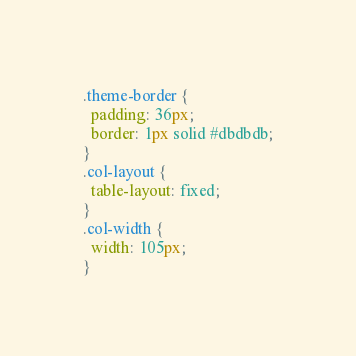Convert code to text. <code><loc_0><loc_0><loc_500><loc_500><_CSS_>.theme-border {
  padding: 36px;
  border: 1px solid #dbdbdb;
}
.col-layout {
  table-layout: fixed;
}
.col-width {
  width: 105px;
}
</code> 